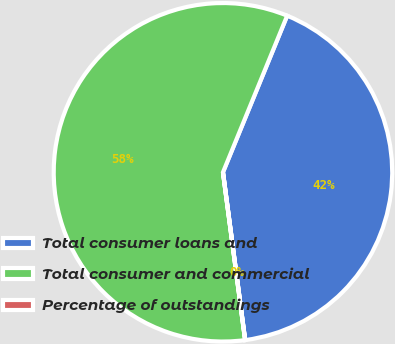Convert chart to OTSL. <chart><loc_0><loc_0><loc_500><loc_500><pie_chart><fcel>Total consumer loans and<fcel>Total consumer and commercial<fcel>Percentage of outstandings<nl><fcel>41.71%<fcel>58.28%<fcel>0.01%<nl></chart> 